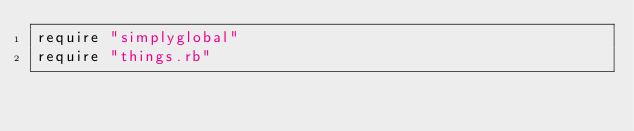Convert code to text. <code><loc_0><loc_0><loc_500><loc_500><_Ruby_>require "simplyglobal"
require "things.rb"
</code> 